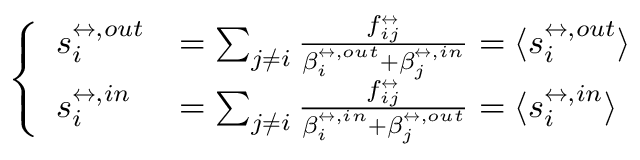<formula> <loc_0><loc_0><loc_500><loc_500>\left \{ \begin{array} { l l } { s _ { i } ^ { \leftrightarrow , o u t } } & { = \sum _ { j \neq i } \frac { f _ { i j } ^ { \leftrightarrow } } { \beta _ { i } ^ { \leftrightarrow , o u t } + \beta _ { j } ^ { \leftrightarrow , i n } } = \langle s _ { i } ^ { \leftrightarrow , o u t } \rangle } \\ { s _ { i } ^ { \leftrightarrow , i n } } & { = \sum _ { j \neq i } \frac { f _ { i j } ^ { \leftrightarrow } } { \beta _ { i } ^ { \leftrightarrow , i n } + \beta _ { j } ^ { \leftrightarrow , o u t } } = \langle s _ { i } ^ { \leftrightarrow , i n } \rangle } \end{array}</formula> 